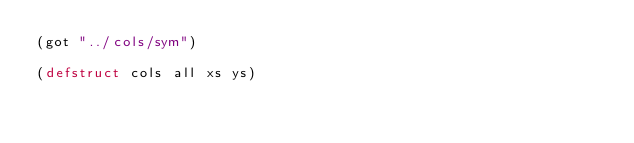Convert code to text. <code><loc_0><loc_0><loc_500><loc_500><_Lisp_>(got "../cols/sym")

(defstruct cols all xs ys)
</code> 